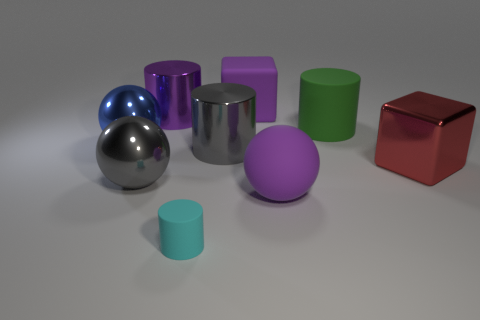Subtract all shiny balls. How many balls are left? 1 Add 1 big red metal blocks. How many objects exist? 10 Subtract all purple cubes. How many cubes are left? 1 Subtract all spheres. How many objects are left? 6 Subtract 1 spheres. How many spheres are left? 2 Subtract all yellow cubes. Subtract all green balls. How many cubes are left? 2 Subtract all large yellow blocks. Subtract all large metal cylinders. How many objects are left? 7 Add 1 big red blocks. How many big red blocks are left? 2 Add 8 cyan matte cylinders. How many cyan matte cylinders exist? 9 Subtract 0 gray blocks. How many objects are left? 9 